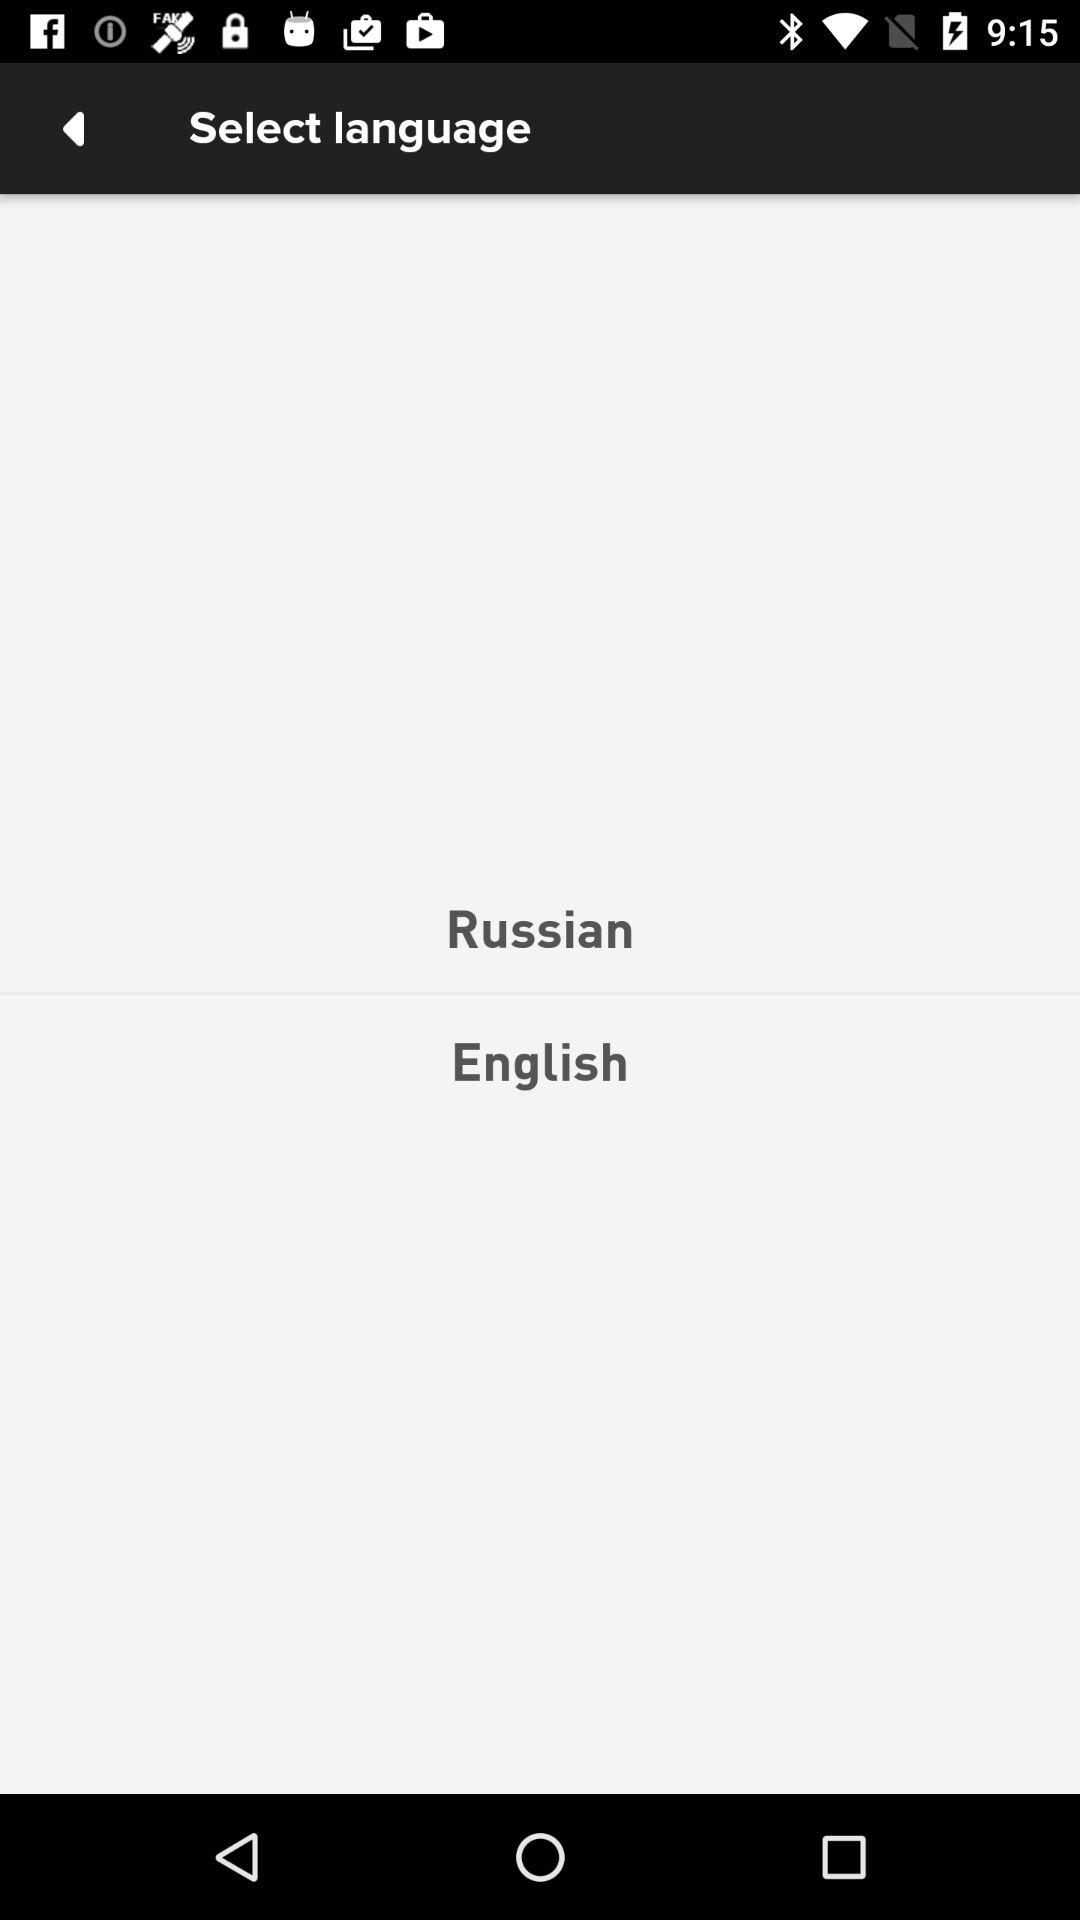What are the different available options for language? The different available options for language are Russian and English. 